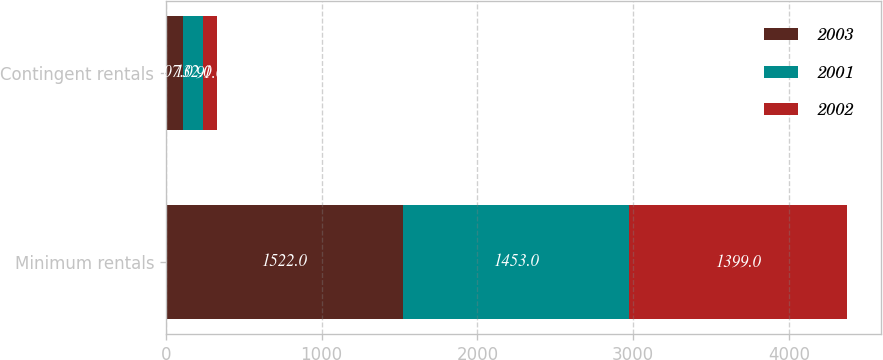Convert chart. <chart><loc_0><loc_0><loc_500><loc_500><stacked_bar_chart><ecel><fcel>Minimum rentals<fcel>Contingent rentals<nl><fcel>2003<fcel>1522<fcel>107<nl><fcel>2001<fcel>1453<fcel>132<nl><fcel>2002<fcel>1399<fcel>91<nl></chart> 